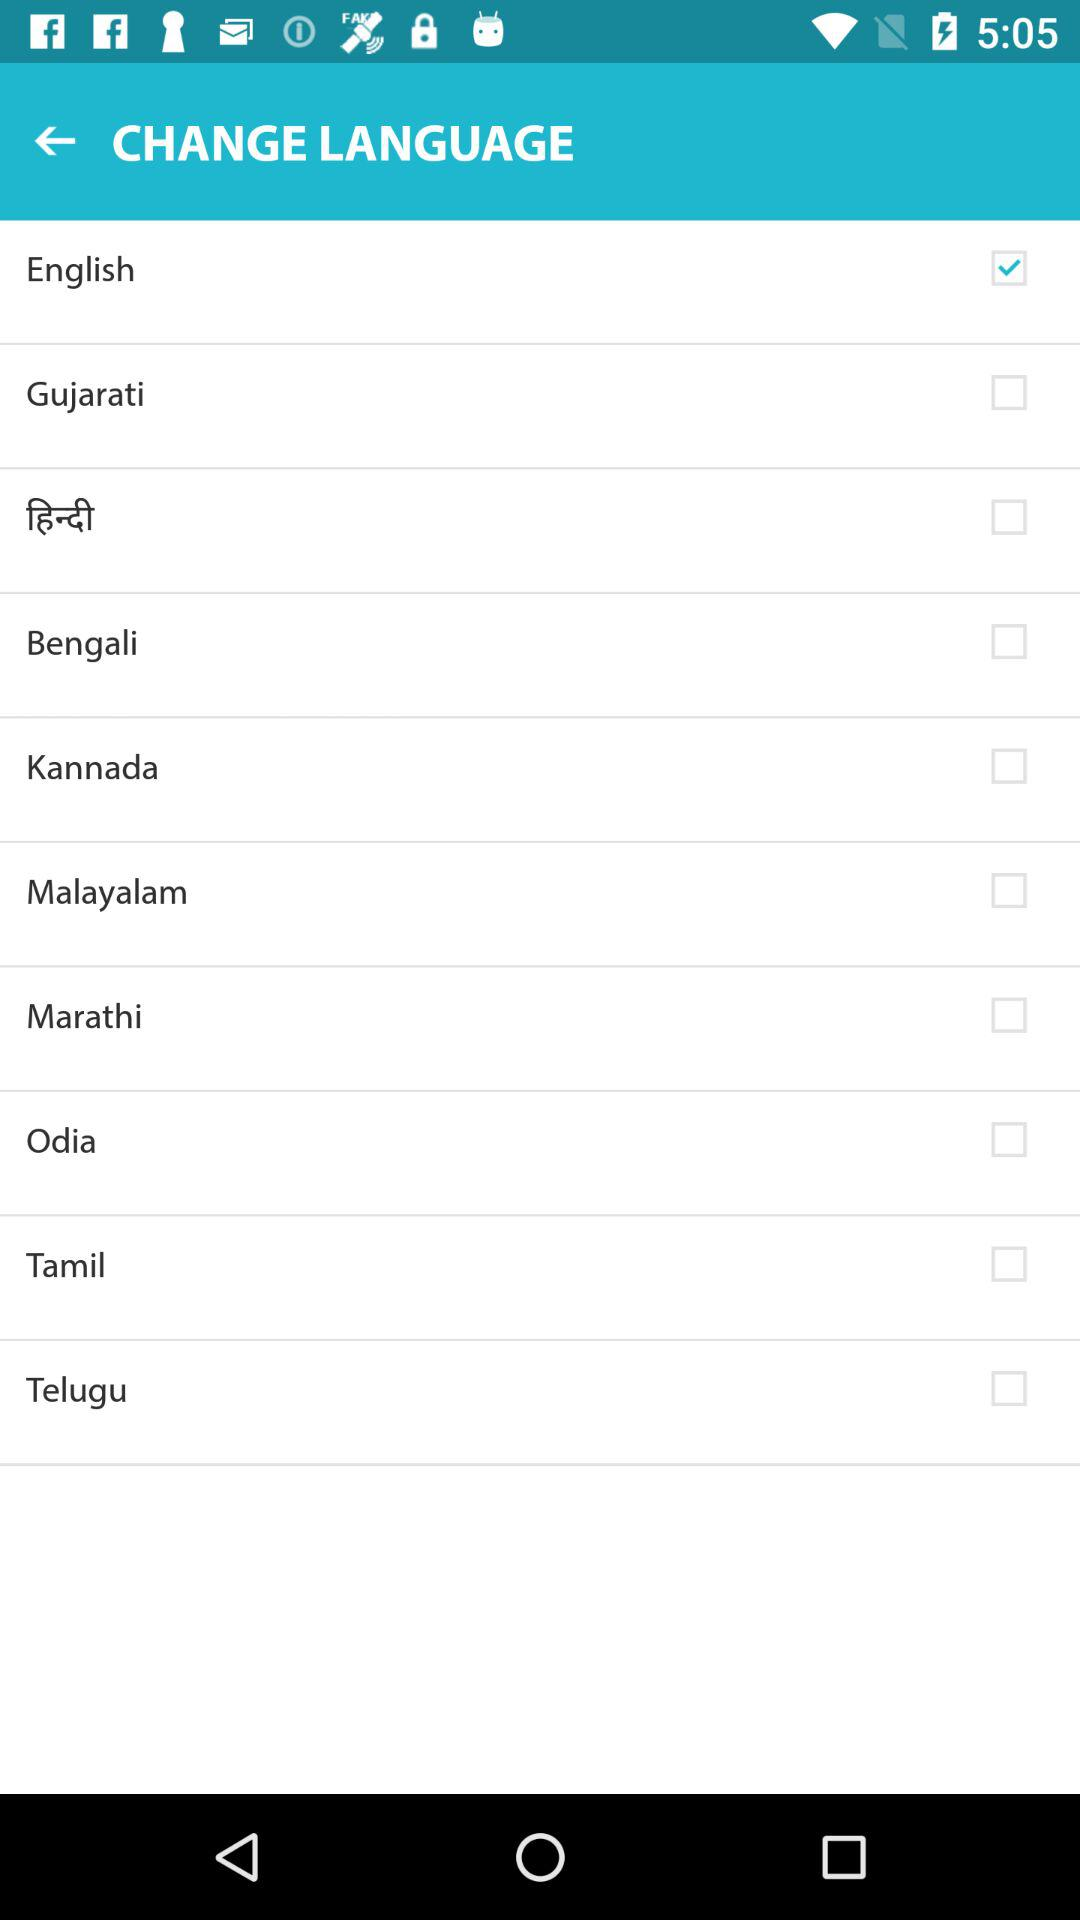What's the selected language? The selected language is "English". 